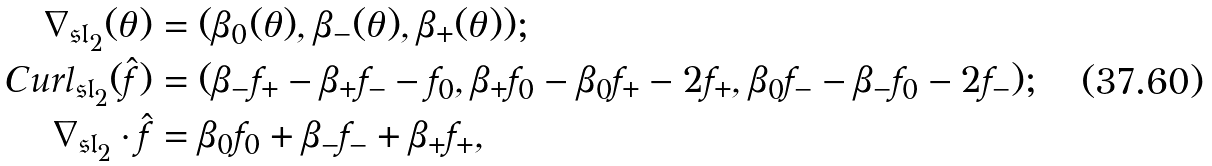Convert formula to latex. <formula><loc_0><loc_0><loc_500><loc_500>\nabla _ { \mathfrak { s l } _ { 2 } } ( \theta ) & = ( \beta _ { 0 } ( \theta ) , \beta _ { - } ( \theta ) , \beta _ { + } ( \theta ) ) ; \\ C u r l _ { \mathfrak { s l } _ { 2 } } ( \hat { f } ) & = ( \beta _ { - } f _ { + } - \beta _ { + } f _ { - } - f _ { 0 } , \beta _ { + } f _ { 0 } - \beta _ { 0 } f _ { + } - 2 f _ { + } , \beta _ { 0 } f _ { - } - \beta _ { - } f _ { 0 } - 2 f _ { - } ) ; \\ \nabla _ { \mathfrak { s l } _ { 2 } } \cdot \hat { f } & = \beta _ { 0 } f _ { 0 } + \beta _ { - } f _ { - } + \beta _ { + } f _ { + } ,</formula> 